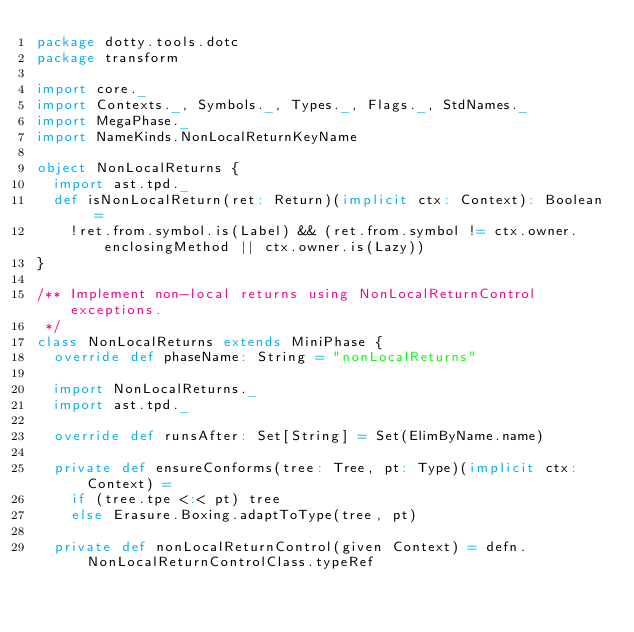Convert code to text. <code><loc_0><loc_0><loc_500><loc_500><_Scala_>package dotty.tools.dotc
package transform

import core._
import Contexts._, Symbols._, Types._, Flags._, StdNames._
import MegaPhase._
import NameKinds.NonLocalReturnKeyName

object NonLocalReturns {
  import ast.tpd._
  def isNonLocalReturn(ret: Return)(implicit ctx: Context): Boolean =
    !ret.from.symbol.is(Label) && (ret.from.symbol != ctx.owner.enclosingMethod || ctx.owner.is(Lazy))
}

/** Implement non-local returns using NonLocalReturnControl exceptions.
 */
class NonLocalReturns extends MiniPhase {
  override def phaseName: String = "nonLocalReturns"

  import NonLocalReturns._
  import ast.tpd._

  override def runsAfter: Set[String] = Set(ElimByName.name)

  private def ensureConforms(tree: Tree, pt: Type)(implicit ctx: Context) =
    if (tree.tpe <:< pt) tree
    else Erasure.Boxing.adaptToType(tree, pt)

  private def nonLocalReturnControl(given Context) = defn.NonLocalReturnControlClass.typeRef
</code> 